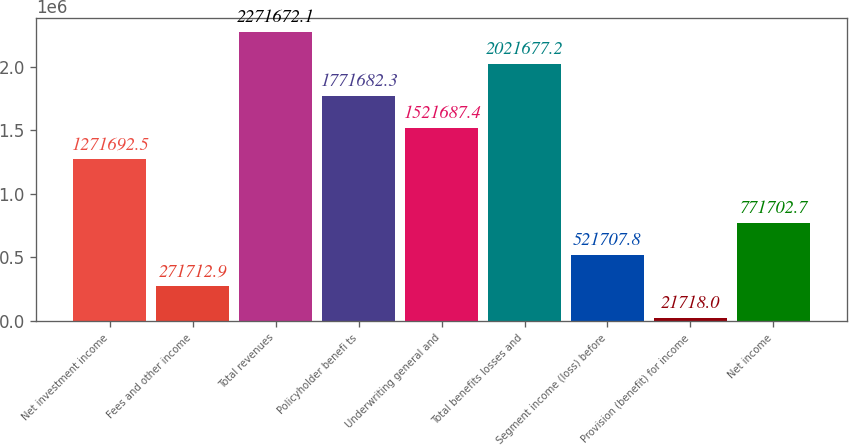Convert chart. <chart><loc_0><loc_0><loc_500><loc_500><bar_chart><fcel>Net investment income<fcel>Fees and other income<fcel>Total revenues<fcel>Policyholder benefi ts<fcel>Underwriting general and<fcel>Total benefits losses and<fcel>Segment income (loss) before<fcel>Provision (benefit) for income<fcel>Net income<nl><fcel>1.27169e+06<fcel>271713<fcel>2.27167e+06<fcel>1.77168e+06<fcel>1.52169e+06<fcel>2.02168e+06<fcel>521708<fcel>21718<fcel>771703<nl></chart> 